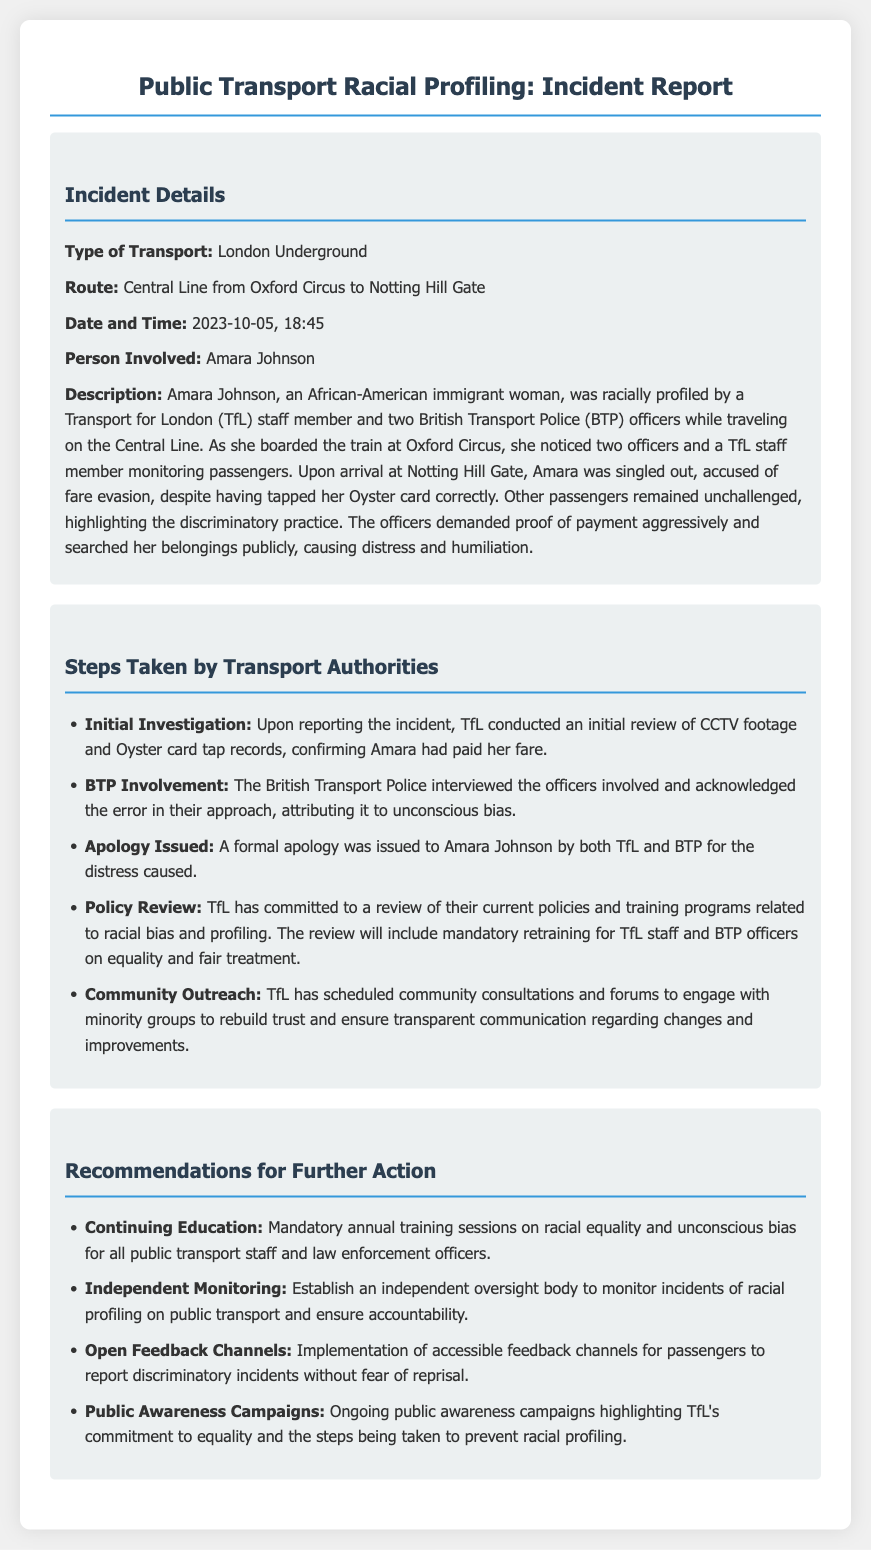what type of transport was involved in the incident? The document specifies the type of transport as the London Underground.
Answer: London Underground what was the route taken during the incident? The route mentioned in the document is from Oxford Circus to Notting Hill Gate.
Answer: Central Line from Oxford Circus to Notting Hill Gate who was the person involved in the incident? The document identifies Amara Johnson as the person involved in the incident.
Answer: Amara Johnson on what date did the incident occur? The document provides the date of the incident as 2023-10-05.
Answer: 2023-10-05 what did Transport for London (TfL) conduct after the incident was reported? The document states that TfL conducted an initial review of CCTV footage and Oyster card tap records.
Answer: Initial investigation what was the reason given by BTP officers for their approach during the incident? The BTP acknowledged the error and attributed it to unconscious bias.
Answer: Unconscious bias which action was committed by TfL due to the incident? The document mentions that TfL committed to a review of their current policies and training programs.
Answer: Policy review what does the report recommend for public transport staff training? The report suggests mandatory annual training sessions on racial equality and unconscious bias.
Answer: Mandatory annual training sessions 